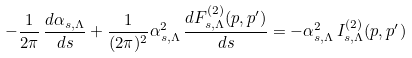<formula> <loc_0><loc_0><loc_500><loc_500>- \frac { 1 } { 2 \pi } \, \frac { d { \alpha } _ { s , \Lambda } } { d s } + \frac { 1 } { ( 2 \pi ) ^ { 2 } } \alpha _ { s , \Lambda } ^ { 2 } \, \frac { d F ^ { ( 2 ) } _ { s , \Lambda } ( p , p ^ { \prime } ) } { d s } = - \alpha _ { s , \Lambda } ^ { 2 } \, I _ { s , \Lambda } ^ { ( 2 ) } ( p , p ^ { \prime } )</formula> 